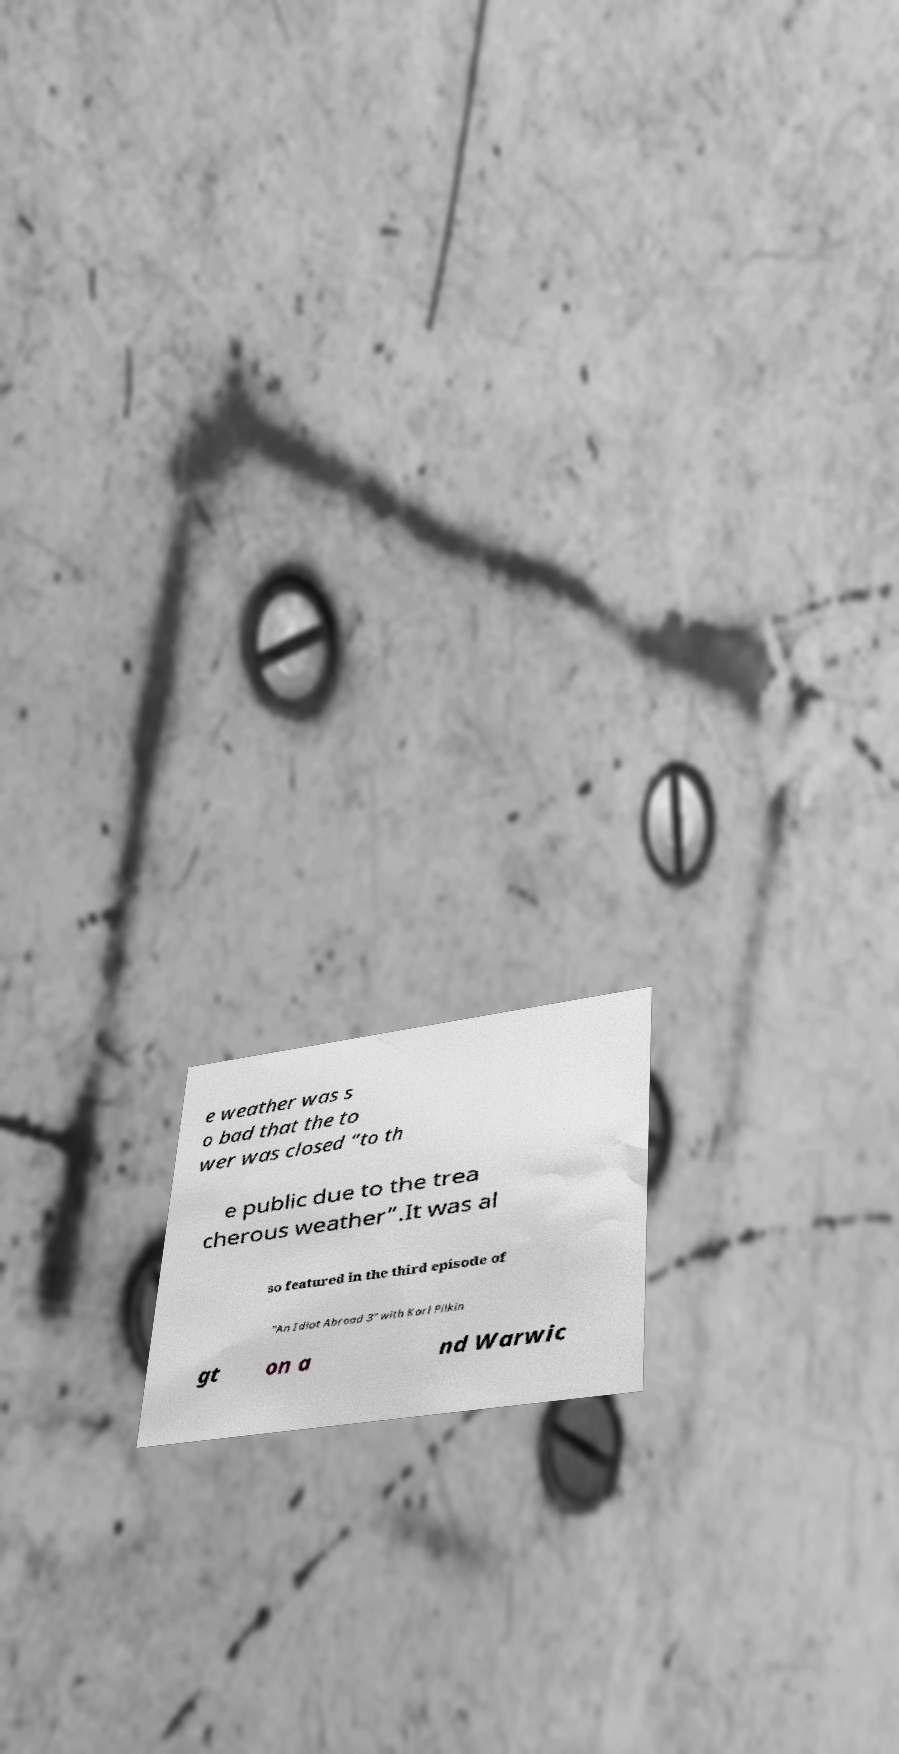Could you assist in decoding the text presented in this image and type it out clearly? e weather was s o bad that the to wer was closed “to th e public due to the trea cherous weather”.It was al so featured in the third episode of "An Idiot Abroad 3" with Karl Pilkin gt on a nd Warwic 